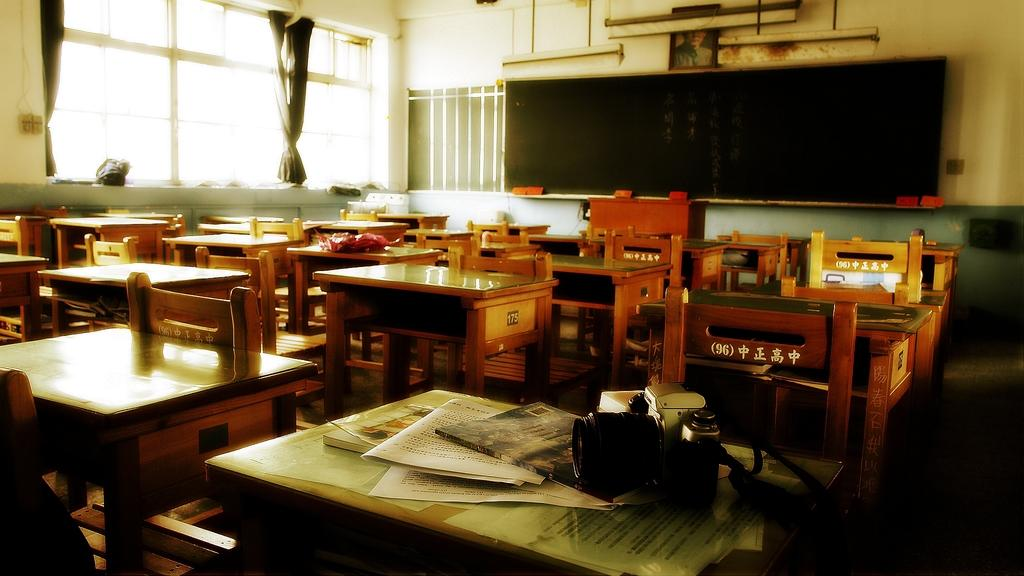What object is the main focus of the image? There is a camera in the image. What else can be seen on the table besides the camera? There are books on the table. How many chairs are visible in the image? There are many chairs in the image. What type of furniture is present in the image besides chairs? There are tables in the image. What is the purpose of the board in the image? The board in the image is likely used for displaying information or as a surface for writing or drawing. What type of window treatment is present in the image? There is a curtain associated with a window. What type of cracker is being used to clean the lens of the camera in the image? There is no cracker present in the image, and the camera lens is not being cleaned. Is the stove in the image turned on or off? There is no stove present in the image. 